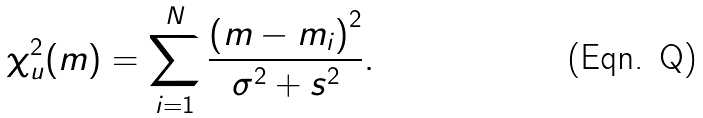Convert formula to latex. <formula><loc_0><loc_0><loc_500><loc_500>\chi _ { u } ^ { 2 } ( m ) = \sum _ { i = 1 } ^ { N } \frac { \left ( m - m _ { i } \right ) ^ { 2 } } { \sigma ^ { 2 } + s ^ { 2 } } .</formula> 